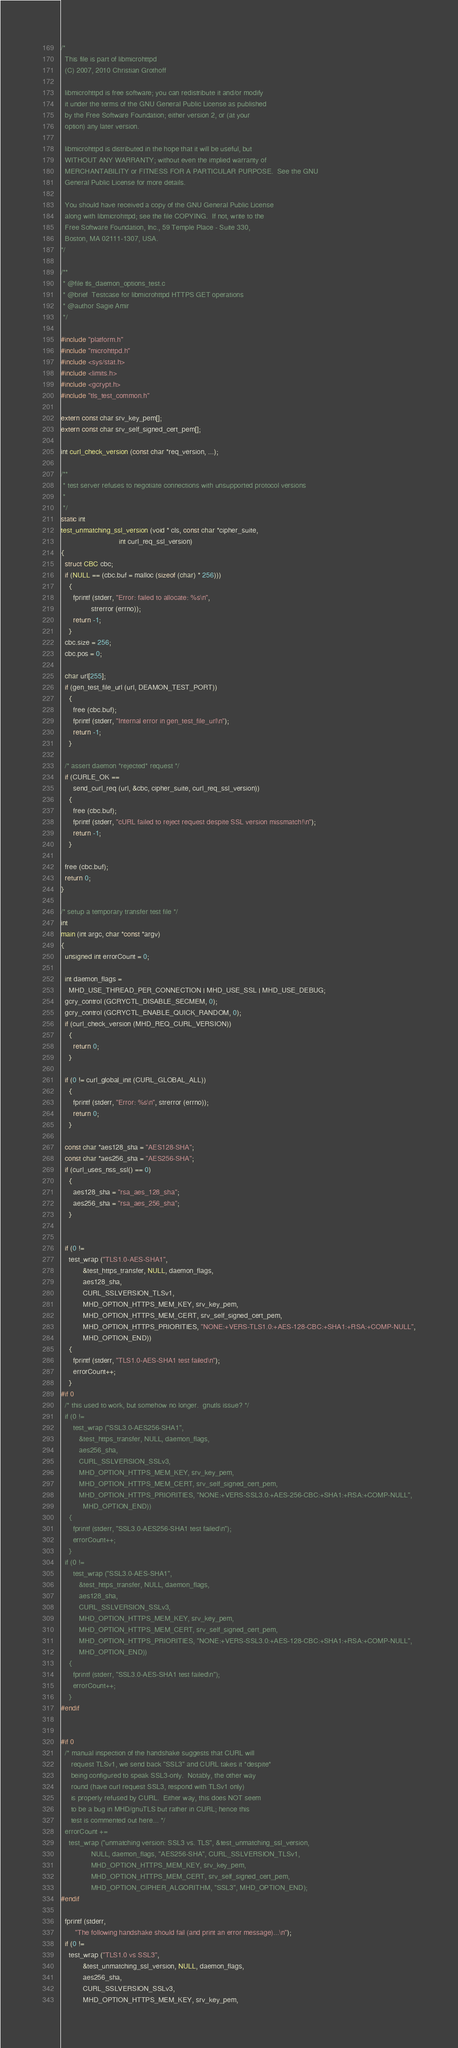Convert code to text. <code><loc_0><loc_0><loc_500><loc_500><_C_>/*
  This file is part of libmicrohttpd
  (C) 2007, 2010 Christian Grothoff
  
  libmicrohttpd is free software; you can redistribute it and/or modify
  it under the terms of the GNU General Public License as published
  by the Free Software Foundation; either version 2, or (at your
  option) any later version.
  
  libmicrohttpd is distributed in the hope that it will be useful, but
  WITHOUT ANY WARRANTY; without even the implied warranty of
  MERCHANTABILITY or FITNESS FOR A PARTICULAR PURPOSE.  See the GNU
  General Public License for more details.
  
  You should have received a copy of the GNU General Public License
  along with libmicrohttpd; see the file COPYING.  If not, write to the
  Free Software Foundation, Inc., 59 Temple Place - Suite 330,
  Boston, MA 02111-1307, USA.
*/

/**
 * @file tls_daemon_options_test.c
 * @brief  Testcase for libmicrohttpd HTTPS GET operations
 * @author Sagie Amir
 */

#include "platform.h"
#include "microhttpd.h"
#include <sys/stat.h>
#include <limits.h>
#include <gcrypt.h>
#include "tls_test_common.h"

extern const char srv_key_pem[];
extern const char srv_self_signed_cert_pem[];

int curl_check_version (const char *req_version, ...);

/**
 * test server refuses to negotiate connections with unsupported protocol versions
 *
 */
static int
test_unmatching_ssl_version (void * cls, const char *cipher_suite,
                             int curl_req_ssl_version)
{
  struct CBC cbc;
  if (NULL == (cbc.buf = malloc (sizeof (char) * 256)))
    {
      fprintf (stderr, "Error: failed to allocate: %s\n",
               strerror (errno));
      return -1;
    }
  cbc.size = 256;
  cbc.pos = 0;

  char url[255];
  if (gen_test_file_url (url, DEAMON_TEST_PORT))
    {
      free (cbc.buf);
      fprintf (stderr, "Internal error in gen_test_file_url\n");
      return -1;
    }

  /* assert daemon *rejected* request */
  if (CURLE_OK ==
      send_curl_req (url, &cbc, cipher_suite, curl_req_ssl_version))
    {
      free (cbc.buf);
      fprintf (stderr, "cURL failed to reject request despite SSL version missmatch!\n");
      return -1;
    }

  free (cbc.buf);
  return 0;
}

/* setup a temporary transfer test file */
int
main (int argc, char *const *argv)
{
  unsigned int errorCount = 0;

  int daemon_flags =
    MHD_USE_THREAD_PER_CONNECTION | MHD_USE_SSL | MHD_USE_DEBUG;
  gcry_control (GCRYCTL_DISABLE_SECMEM, 0);
  gcry_control (GCRYCTL_ENABLE_QUICK_RANDOM, 0);
  if (curl_check_version (MHD_REQ_CURL_VERSION))
    {
      return 0;
    }

  if (0 != curl_global_init (CURL_GLOBAL_ALL))
    {
      fprintf (stderr, "Error: %s\n", strerror (errno));
      return 0; 
    }

  const char *aes128_sha = "AES128-SHA";
  const char *aes256_sha = "AES256-SHA";
  if (curl_uses_nss_ssl() == 0)
    {
      aes128_sha = "rsa_aes_128_sha";
      aes256_sha = "rsa_aes_256_sha";
    }
  

  if (0 != 
    test_wrap ("TLS1.0-AES-SHA1",
	       &test_https_transfer, NULL, daemon_flags,
	       aes128_sha,
	       CURL_SSLVERSION_TLSv1,
	       MHD_OPTION_HTTPS_MEM_KEY, srv_key_pem,
	       MHD_OPTION_HTTPS_MEM_CERT, srv_self_signed_cert_pem,
	       MHD_OPTION_HTTPS_PRIORITIES, "NONE:+VERS-TLS1.0:+AES-128-CBC:+SHA1:+RSA:+COMP-NULL",
	       MHD_OPTION_END))
    {
      fprintf (stderr, "TLS1.0-AES-SHA1 test failed\n");
      errorCount++;
    }
#if 0
  /* this used to work, but somehow no longer.  gnutls issue? */
  if (0 != 
      test_wrap ("SSL3.0-AES256-SHA1", 
		 &test_https_transfer, NULL, daemon_flags,
		 aes256_sha,
		 CURL_SSLVERSION_SSLv3,
		 MHD_OPTION_HTTPS_MEM_KEY, srv_key_pem,
		 MHD_OPTION_HTTPS_MEM_CERT, srv_self_signed_cert_pem,
		 MHD_OPTION_HTTPS_PRIORITIES, "NONE:+VERS-SSL3.0:+AES-256-CBC:+SHA1:+RSA:+COMP-NULL",
	       MHD_OPTION_END))
    {
      fprintf (stderr, "SSL3.0-AES256-SHA1 test failed\n");
      errorCount++;
    }
  if (0 !=
      test_wrap ("SSL3.0-AES-SHA1",
		 &test_https_transfer, NULL, daemon_flags,
		 aes128_sha,
		 CURL_SSLVERSION_SSLv3,
		 MHD_OPTION_HTTPS_MEM_KEY, srv_key_pem,
		 MHD_OPTION_HTTPS_MEM_CERT, srv_self_signed_cert_pem,
		 MHD_OPTION_HTTPS_PRIORITIES, "NONE:+VERS-SSL3.0:+AES-128-CBC:+SHA1:+RSA:+COMP-NULL",
		 MHD_OPTION_END))
    {
      fprintf (stderr, "SSL3.0-AES-SHA1 test failed\n");
      errorCount++;
    }
#endif


#if 0
  /* manual inspection of the handshake suggests that CURL will
     request TLSv1, we send back "SSL3" and CURL takes it *despite*
     being configured to speak SSL3-only.  Notably, the other way
     round (have curl request SSL3, respond with TLSv1 only)
     is properly refused by CURL.  Either way, this does NOT seem
     to be a bug in MHD/gnuTLS but rather in CURL; hence this
     test is commented out here... */
  errorCount +=
    test_wrap ("unmatching version: SSL3 vs. TLS", &test_unmatching_ssl_version,
               NULL, daemon_flags, "AES256-SHA", CURL_SSLVERSION_TLSv1,
               MHD_OPTION_HTTPS_MEM_KEY, srv_key_pem,
               MHD_OPTION_HTTPS_MEM_CERT, srv_self_signed_cert_pem,
               MHD_OPTION_CIPHER_ALGORITHM, "SSL3", MHD_OPTION_END);
#endif

  fprintf (stderr,
	   "The following handshake should fail (and print an error message)...\n");
  if (0 !=
    test_wrap ("TLS1.0 vs SSL3",
	       &test_unmatching_ssl_version, NULL, daemon_flags,
	       aes256_sha,
	       CURL_SSLVERSION_SSLv3,
	       MHD_OPTION_HTTPS_MEM_KEY, srv_key_pem,</code> 